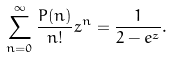<formula> <loc_0><loc_0><loc_500><loc_500>\sum _ { n = 0 } ^ { \infty } \frac { P ( n ) } { n ! } z ^ { n } = \frac { 1 } { 2 - e ^ { z } } .</formula> 